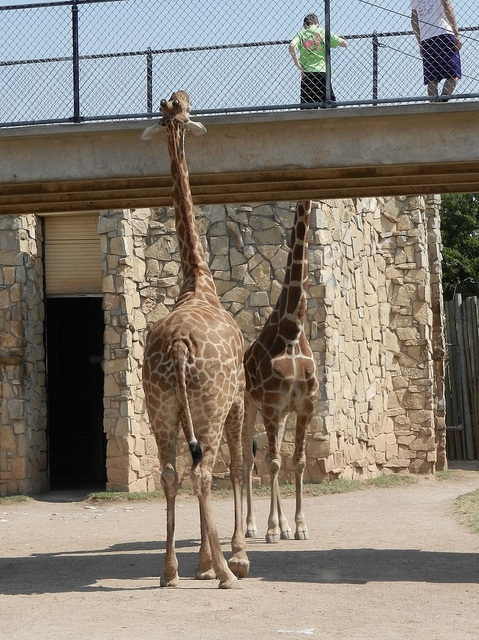Describe the objects in this image and their specific colors. I can see giraffe in lightblue, maroon, gray, and tan tones, giraffe in lightblue, black, gray, and maroon tones, people in lightblue, black, gray, darkgray, and navy tones, and people in lightblue, black, gray, green, and darkgray tones in this image. 